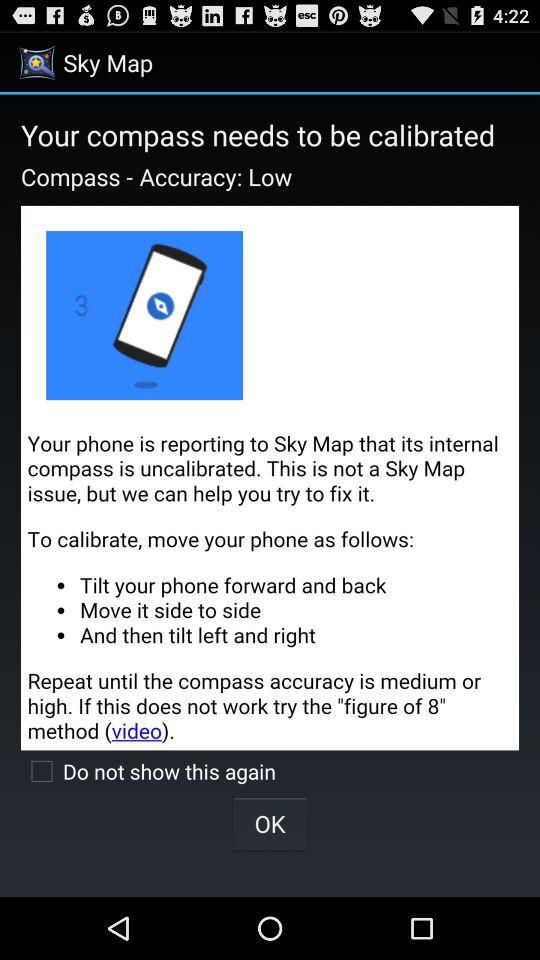What is the accuracy of the compass? The accuracy of the compass is low. 